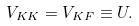Convert formula to latex. <formula><loc_0><loc_0><loc_500><loc_500>V _ { K K } = V _ { K F } \equiv U .</formula> 